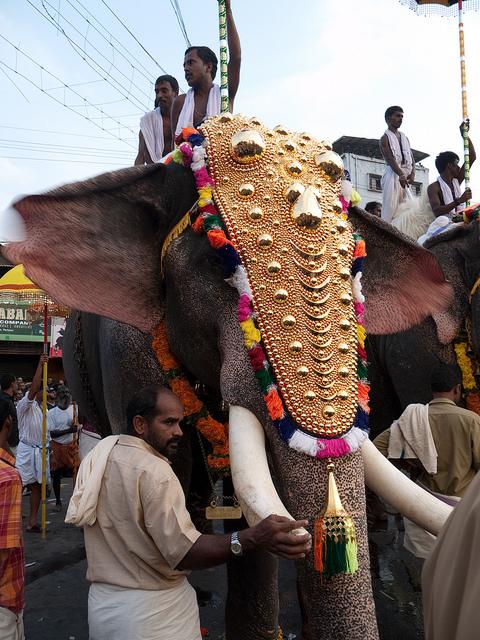Are people on the top of the elephant?
Be succinct. Yes. Could this be a celebration?
Give a very brief answer. Yes. Yes it could be?
Quick response, please. No. How many elephants are there?
Answer briefly. 1. 